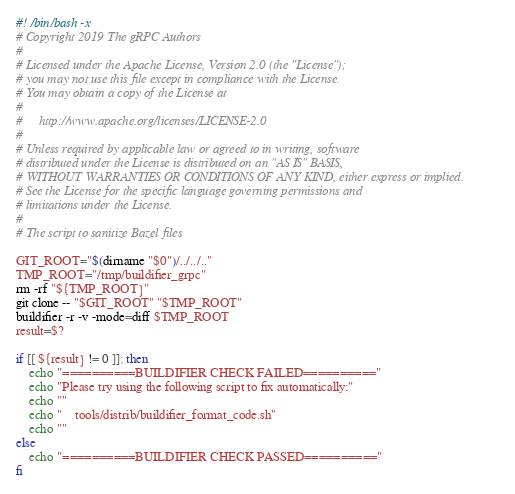<code> <loc_0><loc_0><loc_500><loc_500><_Bash_>#! /bin/bash -x
# Copyright 2019 The gRPC Authors
#
# Licensed under the Apache License, Version 2.0 (the "License");
# you may not use this file except in compliance with the License.
# You may obtain a copy of the License at
#
#     http://www.apache.org/licenses/LICENSE-2.0
#
# Unless required by applicable law or agreed to in writing, software
# distributed under the License is distributed on an "AS IS" BASIS,
# WITHOUT WARRANTIES OR CONDITIONS OF ANY KIND, either express or implied.
# See the License for the specific language governing permissions and
# limitations under the License.
#
# The script to sanitize Bazel files

GIT_ROOT="$(dirname "$0")/../../.."
TMP_ROOT="/tmp/buildifier_grpc"
rm -rf "${TMP_ROOT}"
git clone -- "$GIT_ROOT" "$TMP_ROOT"
buildifier -r -v -mode=diff $TMP_ROOT
result=$?

if [[ ${result} != 0 ]]; then
    echo "==========BUILDIFIER CHECK FAILED=========="
    echo "Please try using the following script to fix automatically:"
    echo ""
    echo "    tools/distrib/buildifier_format_code.sh"
    echo ""
else
    echo "==========BUILDIFIER CHECK PASSED=========="
fi
</code> 